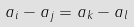<formula> <loc_0><loc_0><loc_500><loc_500>a _ { i } - a _ { j } = a _ { k } - a _ { l }</formula> 